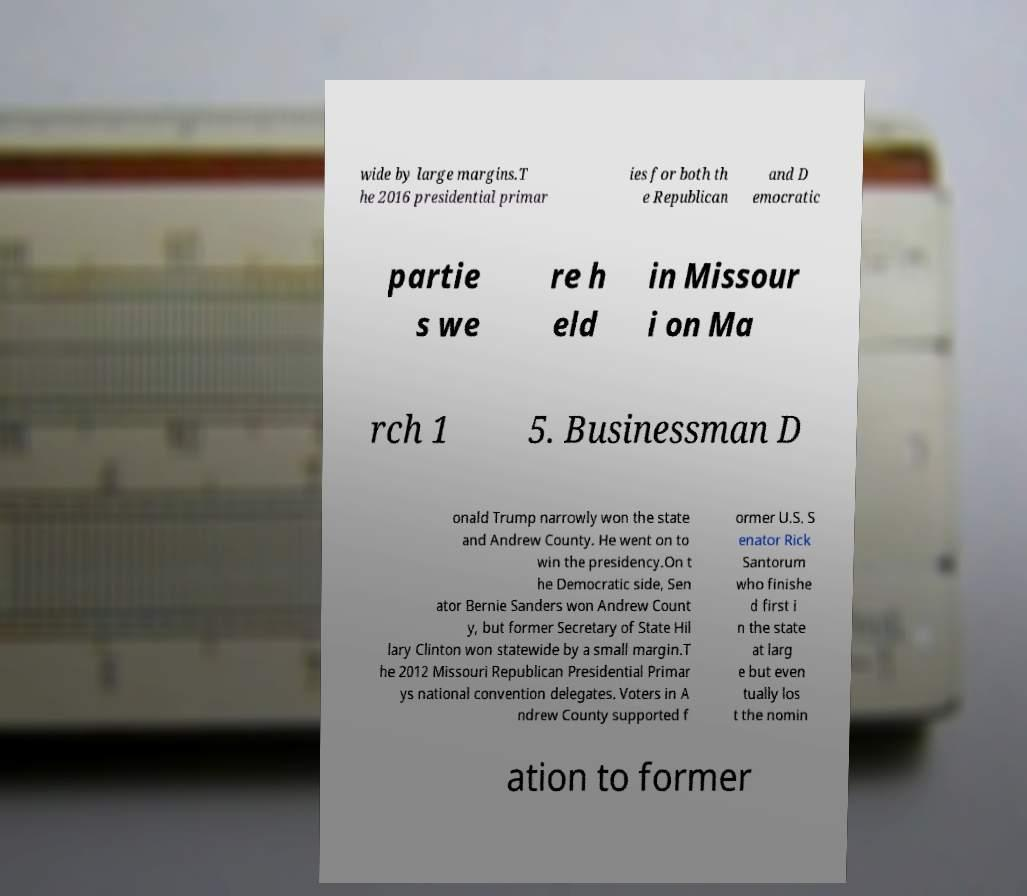Can you accurately transcribe the text from the provided image for me? wide by large margins.T he 2016 presidential primar ies for both th e Republican and D emocratic partie s we re h eld in Missour i on Ma rch 1 5. Businessman D onald Trump narrowly won the state and Andrew County. He went on to win the presidency.On t he Democratic side, Sen ator Bernie Sanders won Andrew Count y, but former Secretary of State Hil lary Clinton won statewide by a small margin.T he 2012 Missouri Republican Presidential Primar ys national convention delegates. Voters in A ndrew County supported f ormer U.S. S enator Rick Santorum who finishe d first i n the state at larg e but even tually los t the nomin ation to former 